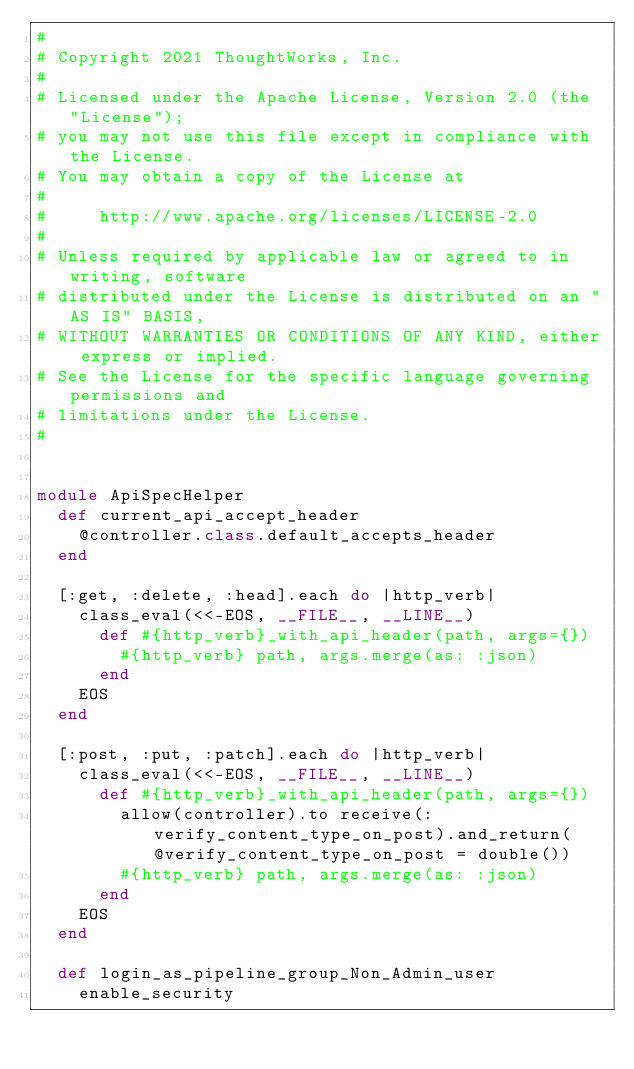Convert code to text. <code><loc_0><loc_0><loc_500><loc_500><_Ruby_>#
# Copyright 2021 ThoughtWorks, Inc.
#
# Licensed under the Apache License, Version 2.0 (the "License");
# you may not use this file except in compliance with the License.
# You may obtain a copy of the License at
#
#     http://www.apache.org/licenses/LICENSE-2.0
#
# Unless required by applicable law or agreed to in writing, software
# distributed under the License is distributed on an "AS IS" BASIS,
# WITHOUT WARRANTIES OR CONDITIONS OF ANY KIND, either express or implied.
# See the License for the specific language governing permissions and
# limitations under the License.
#


module ApiSpecHelper
  def current_api_accept_header
    @controller.class.default_accepts_header
  end

  [:get, :delete, :head].each do |http_verb|
    class_eval(<<-EOS, __FILE__, __LINE__)
      def #{http_verb}_with_api_header(path, args={})
        #{http_verb} path, args.merge(as: :json)
      end
    EOS
  end

  [:post, :put, :patch].each do |http_verb|
    class_eval(<<-EOS, __FILE__, __LINE__)
      def #{http_verb}_with_api_header(path, args={})
        allow(controller).to receive(:verify_content_type_on_post).and_return(@verify_content_type_on_post = double())
        #{http_verb} path, args.merge(as: :json)
      end
    EOS
  end

  def login_as_pipeline_group_Non_Admin_user
    enable_security</code> 